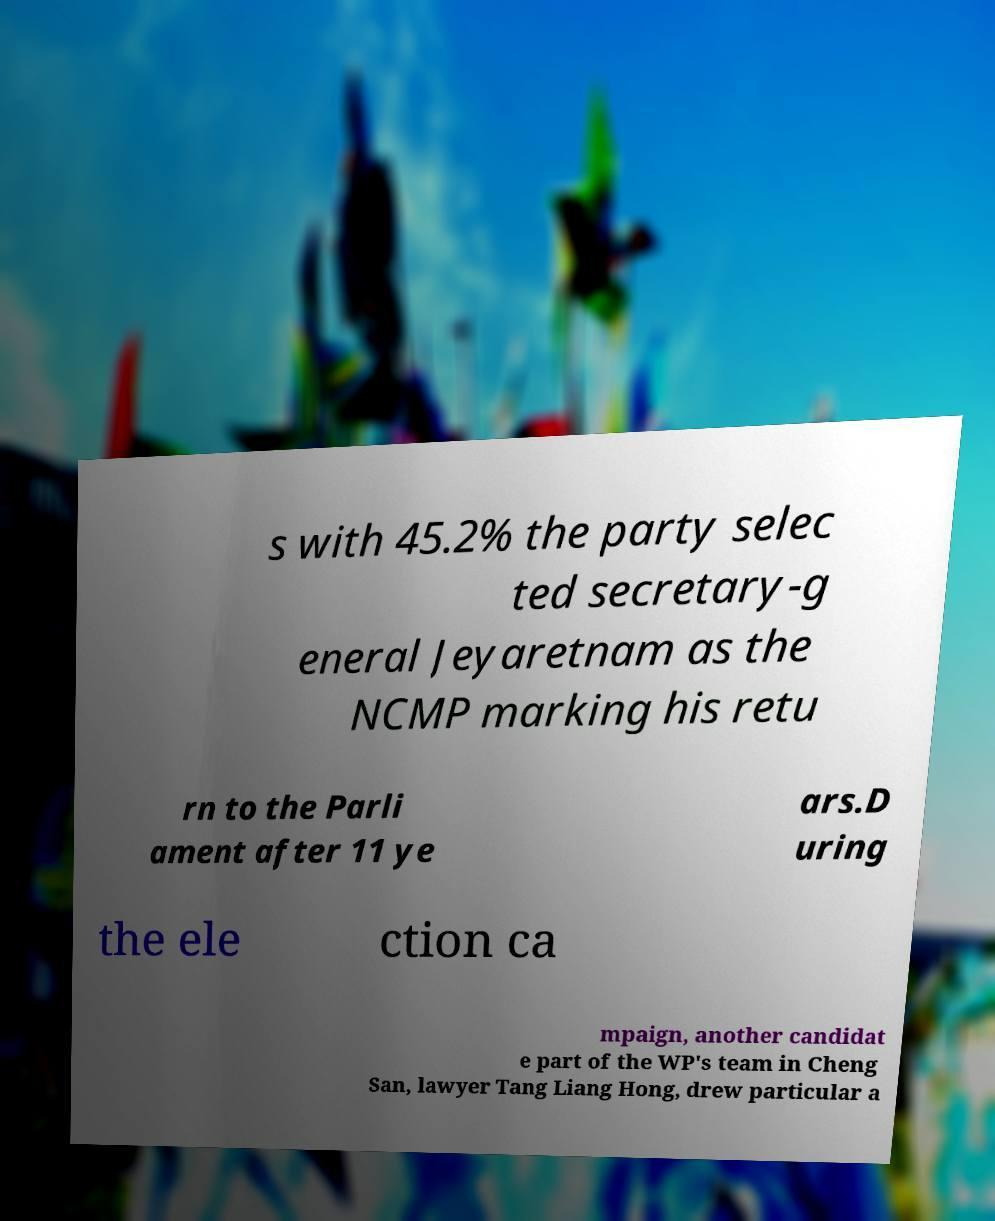Could you extract and type out the text from this image? s with 45.2% the party selec ted secretary-g eneral Jeyaretnam as the NCMP marking his retu rn to the Parli ament after 11 ye ars.D uring the ele ction ca mpaign, another candidat e part of the WP's team in Cheng San, lawyer Tang Liang Hong, drew particular a 